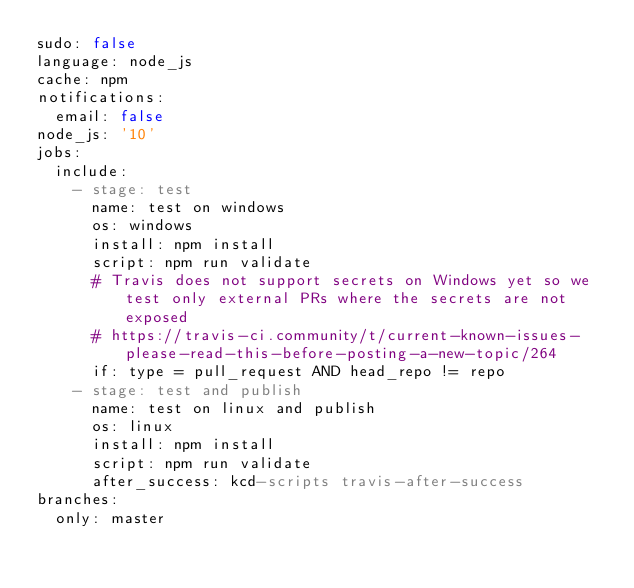Convert code to text. <code><loc_0><loc_0><loc_500><loc_500><_YAML_>sudo: false
language: node_js
cache: npm
notifications:
  email: false
node_js: '10'
jobs:
  include:
    - stage: test
      name: test on windows
      os: windows
      install: npm install
      script: npm run validate
      # Travis does not support secrets on Windows yet so we test only external PRs where the secrets are not exposed
      # https://travis-ci.community/t/current-known-issues-please-read-this-before-posting-a-new-topic/264
      if: type = pull_request AND head_repo != repo
    - stage: test and publish
      name: test on linux and publish
      os: linux
      install: npm install
      script: npm run validate
      after_success: kcd-scripts travis-after-success
branches:
  only: master
</code> 